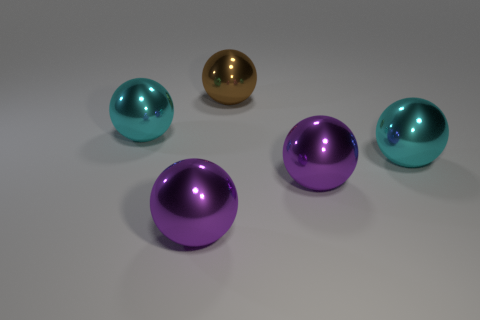Subtract all brown spheres. How many spheres are left? 4 Subtract all brown shiny balls. How many balls are left? 4 Subtract 2 spheres. How many spheres are left? 3 Subtract all green balls. Subtract all brown cylinders. How many balls are left? 5 Add 5 brown metal things. How many objects exist? 10 Subtract all green rubber objects. Subtract all cyan metal balls. How many objects are left? 3 Add 3 large cyan metal balls. How many large cyan metal balls are left? 5 Add 2 cyan balls. How many cyan balls exist? 4 Subtract 0 red cubes. How many objects are left? 5 